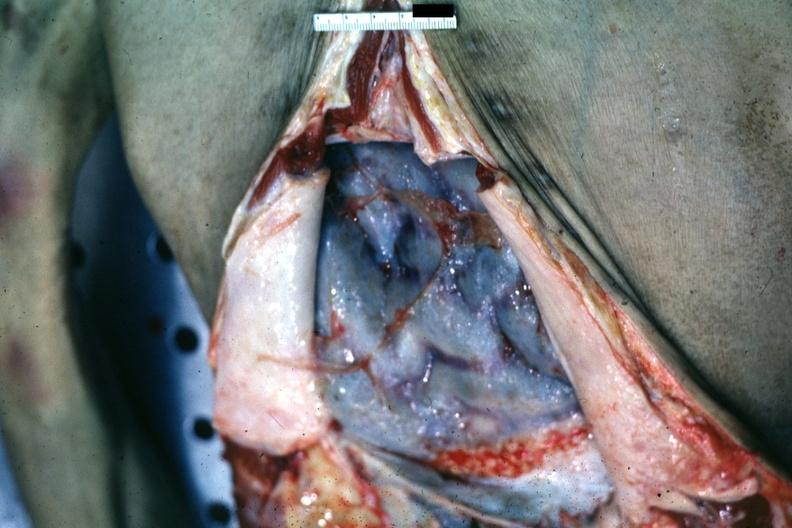s abdomen present?
Answer the question using a single word or phrase. Yes 